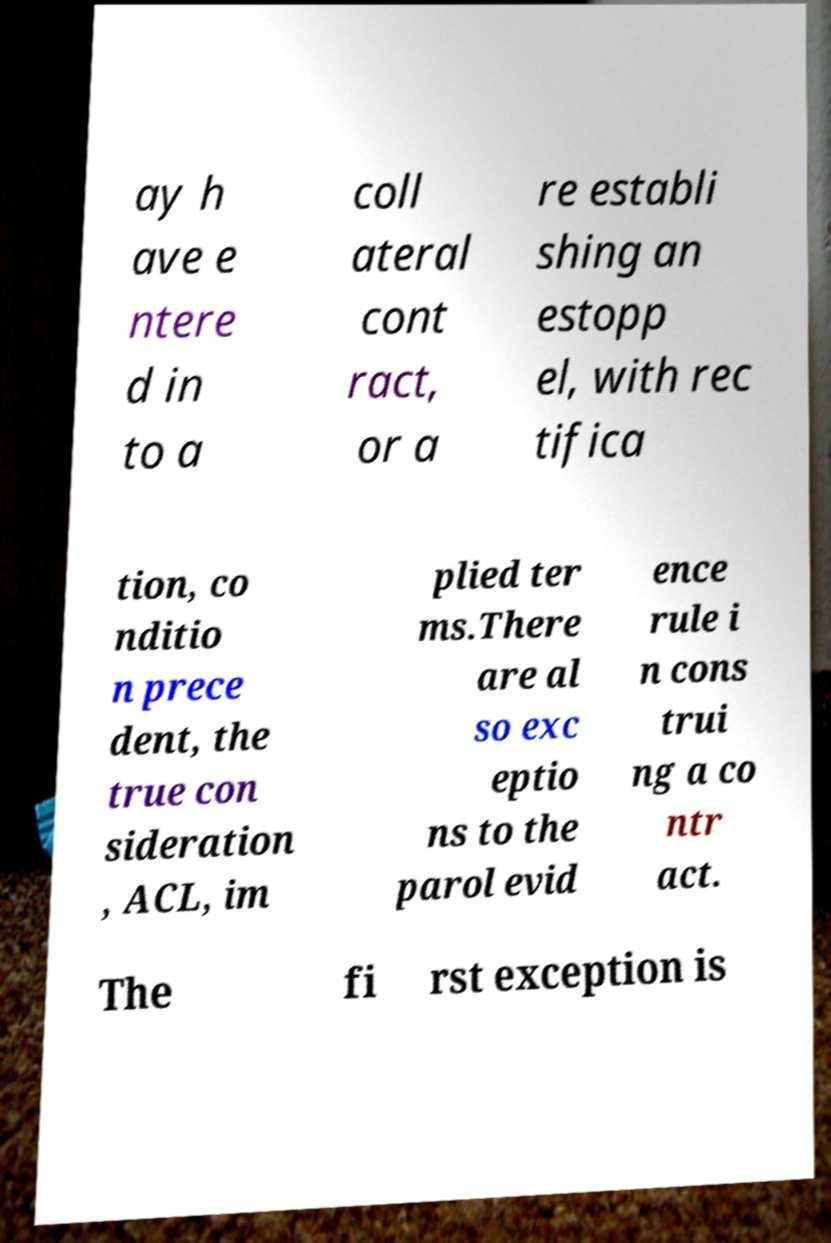Could you assist in decoding the text presented in this image and type it out clearly? ay h ave e ntere d in to a coll ateral cont ract, or a re establi shing an estopp el, with rec tifica tion, co nditio n prece dent, the true con sideration , ACL, im plied ter ms.There are al so exc eptio ns to the parol evid ence rule i n cons trui ng a co ntr act. The fi rst exception is 